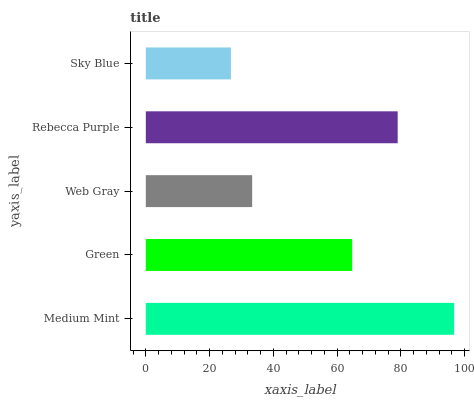Is Sky Blue the minimum?
Answer yes or no. Yes. Is Medium Mint the maximum?
Answer yes or no. Yes. Is Green the minimum?
Answer yes or no. No. Is Green the maximum?
Answer yes or no. No. Is Medium Mint greater than Green?
Answer yes or no. Yes. Is Green less than Medium Mint?
Answer yes or no. Yes. Is Green greater than Medium Mint?
Answer yes or no. No. Is Medium Mint less than Green?
Answer yes or no. No. Is Green the high median?
Answer yes or no. Yes. Is Green the low median?
Answer yes or no. Yes. Is Web Gray the high median?
Answer yes or no. No. Is Medium Mint the low median?
Answer yes or no. No. 